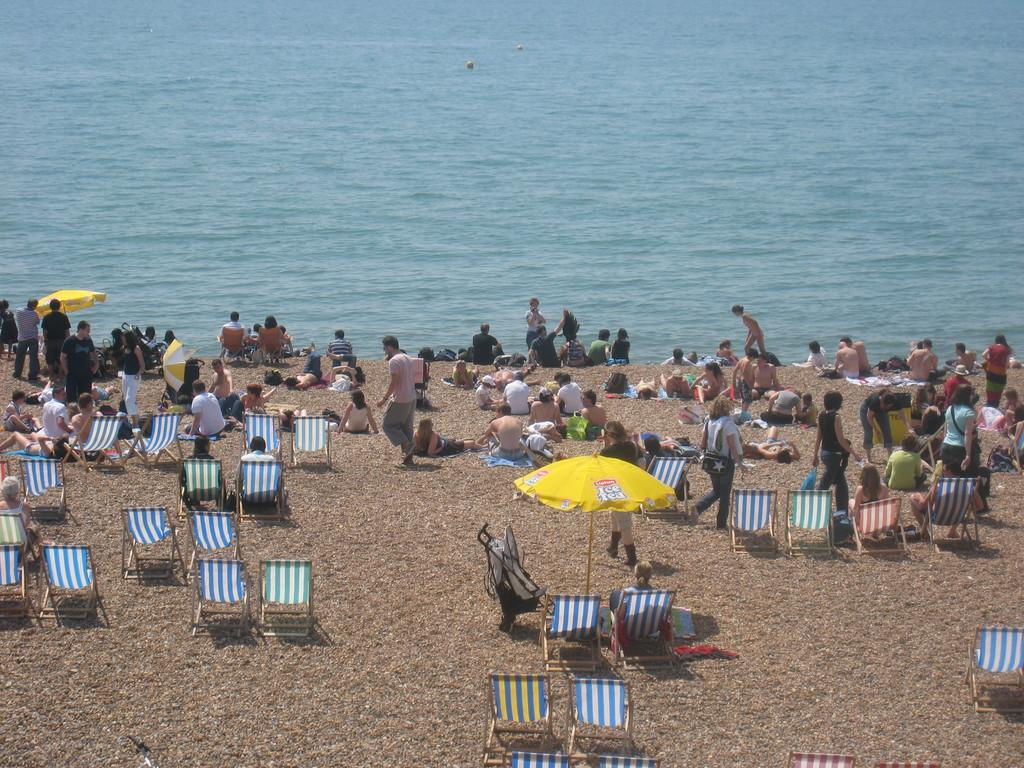How many people are in the image? There are people in the image, but the exact number is not specified. What are some of the people doing in the image? Some people are sitting, and some are walking. What can be seen in the background of the image? There is water visible in the image. What type of furniture is present in the image? There are chairs in the image. Can you describe any other objects in the image? There are other unspecified objects in the image. What type of hat is the person wearing in the image? There is no mention of a hat in the image, so it cannot be determined if someone is wearing one. What type of drink is the person holding in the image? There is no mention of a drink in the image, so it cannot be determined if someone is holding one. 